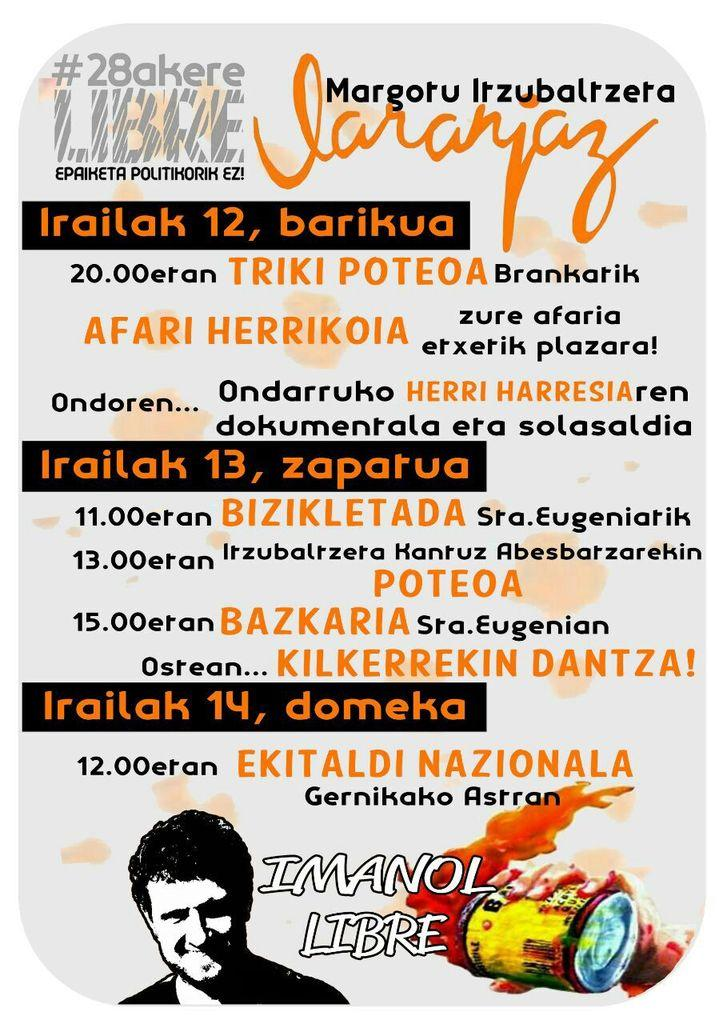What is present in the image that contains both images and text? There is a poster in the image that contains images and text. What grade does the poster receive for its design in the image? The image does not contain any information about the poster's design or a grading system, so it is not possible to answer that question. 